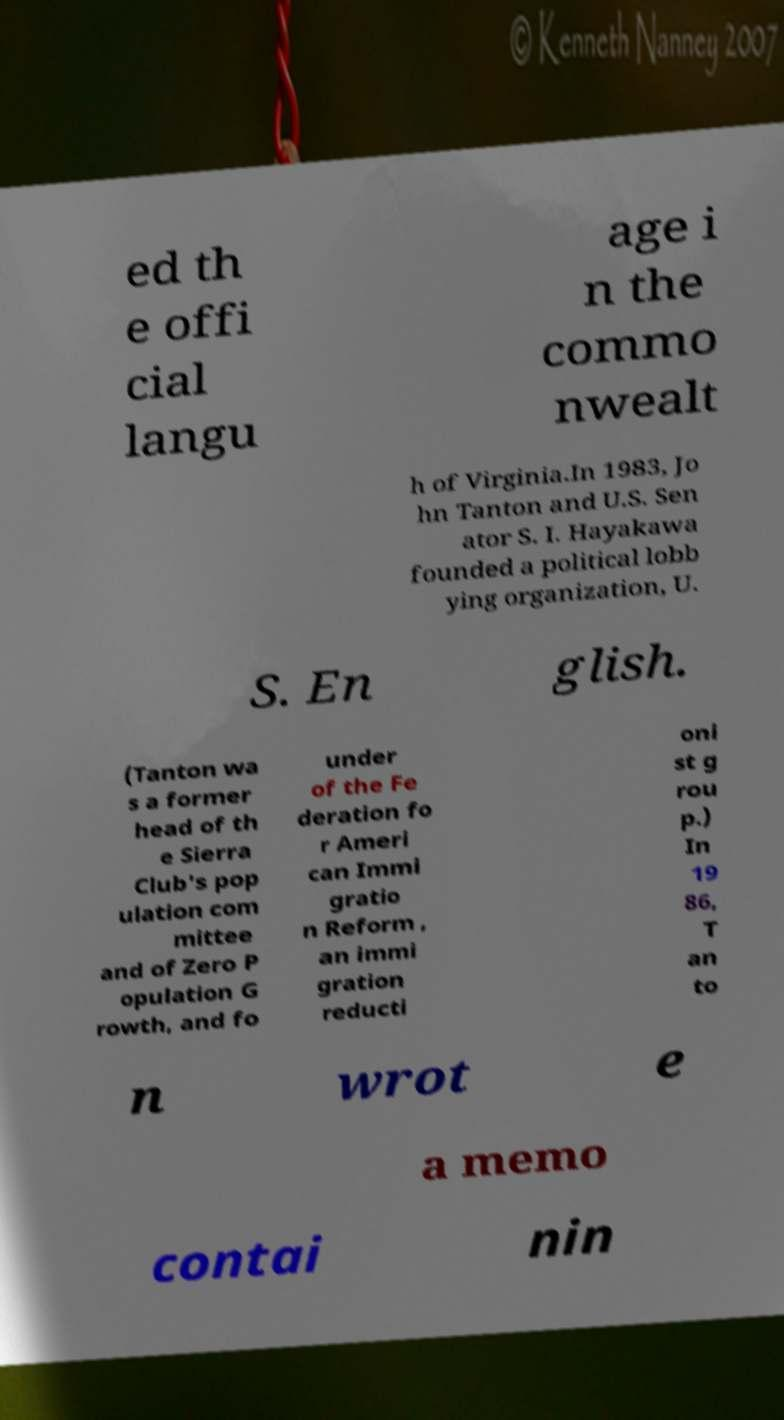I need the written content from this picture converted into text. Can you do that? ed th e offi cial langu age i n the commo nwealt h of Virginia.In 1983, Jo hn Tanton and U.S. Sen ator S. I. Hayakawa founded a political lobb ying organization, U. S. En glish. (Tanton wa s a former head of th e Sierra Club's pop ulation com mittee and of Zero P opulation G rowth, and fo under of the Fe deration fo r Ameri can Immi gratio n Reform , an immi gration reducti oni st g rou p.) In 19 86, T an to n wrot e a memo contai nin 